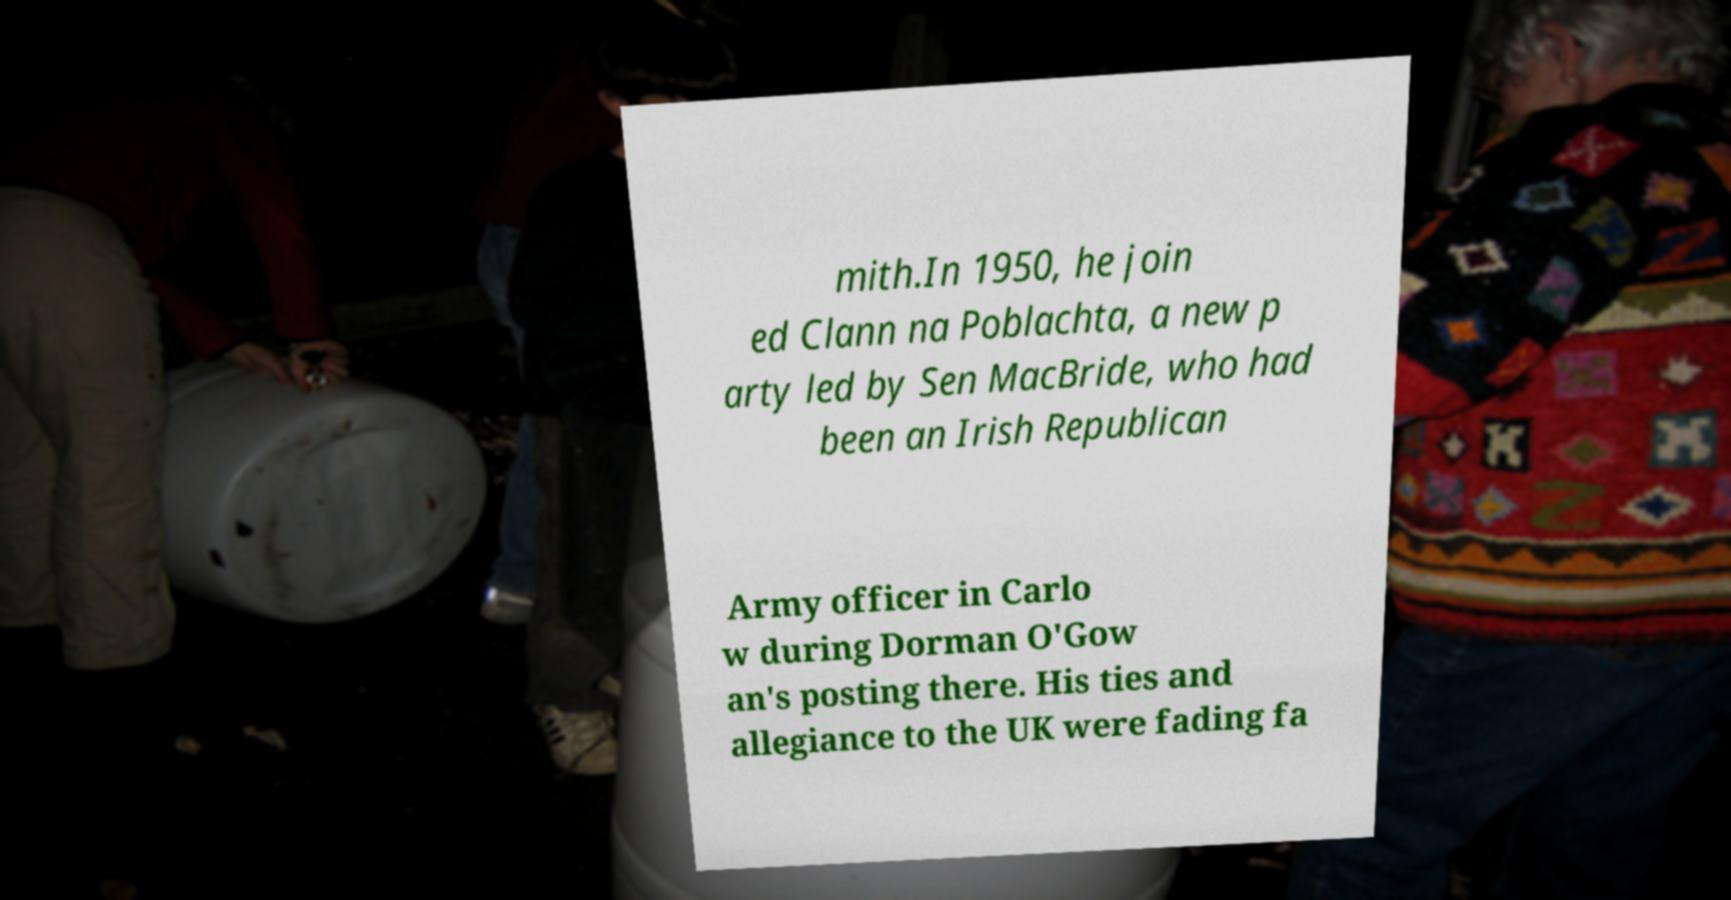Could you extract and type out the text from this image? mith.In 1950, he join ed Clann na Poblachta, a new p arty led by Sen MacBride, who had been an Irish Republican Army officer in Carlo w during Dorman O'Gow an's posting there. His ties and allegiance to the UK were fading fa 